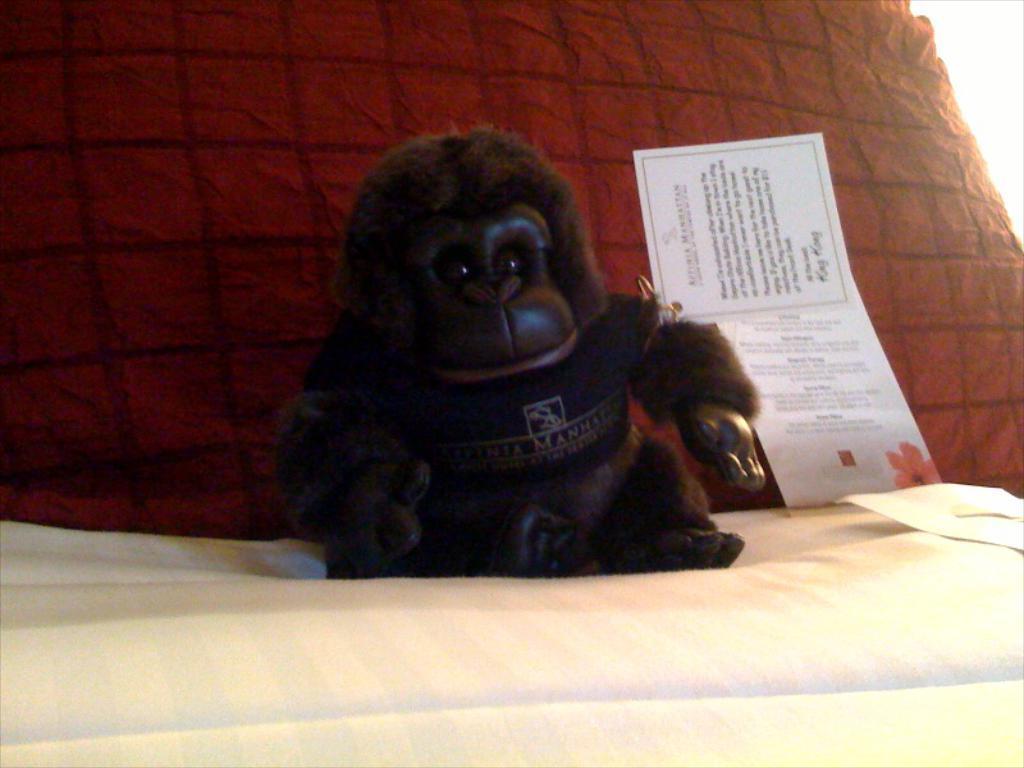Describe this image in one or two sentences. In this picture we can see a toy and cards on a cloth and in the background we can see a red pillow. 